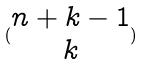<formula> <loc_0><loc_0><loc_500><loc_500>( \begin{matrix} n + k - 1 \\ k \end{matrix} )</formula> 